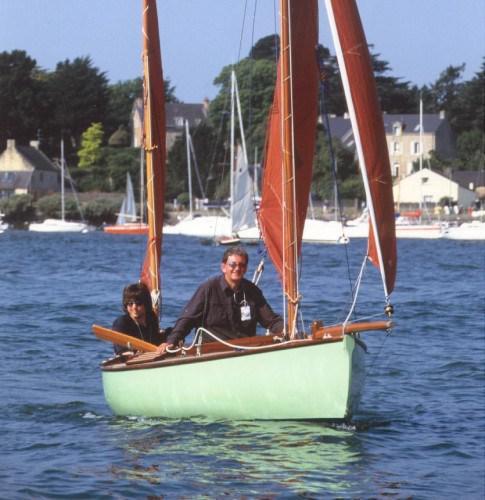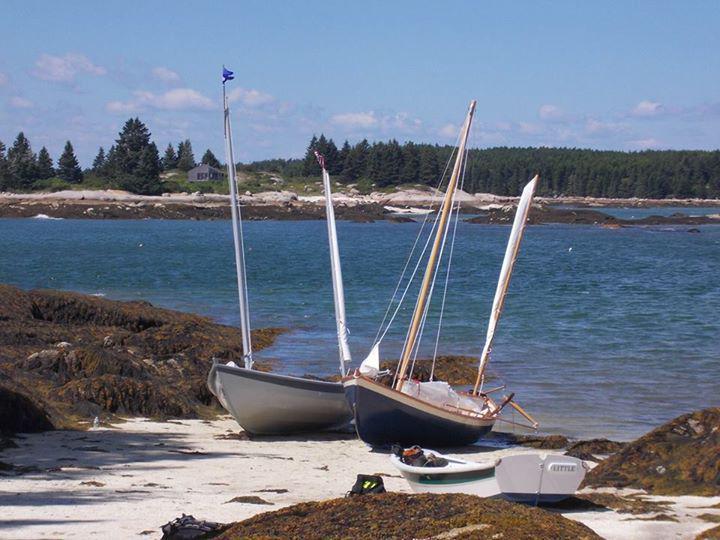The first image is the image on the left, the second image is the image on the right. For the images shown, is this caption "People are in two boats in the water in the image on the left." true? Answer yes or no. No. 